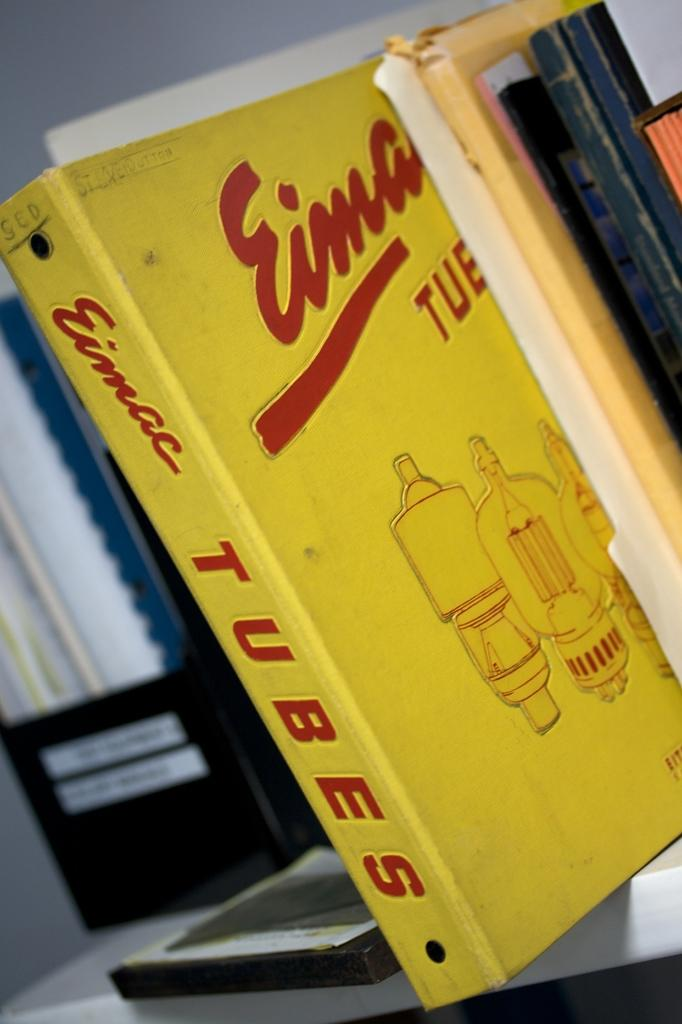<image>
Offer a succinct explanation of the picture presented. book spike placed on the bookshelf called tubes 